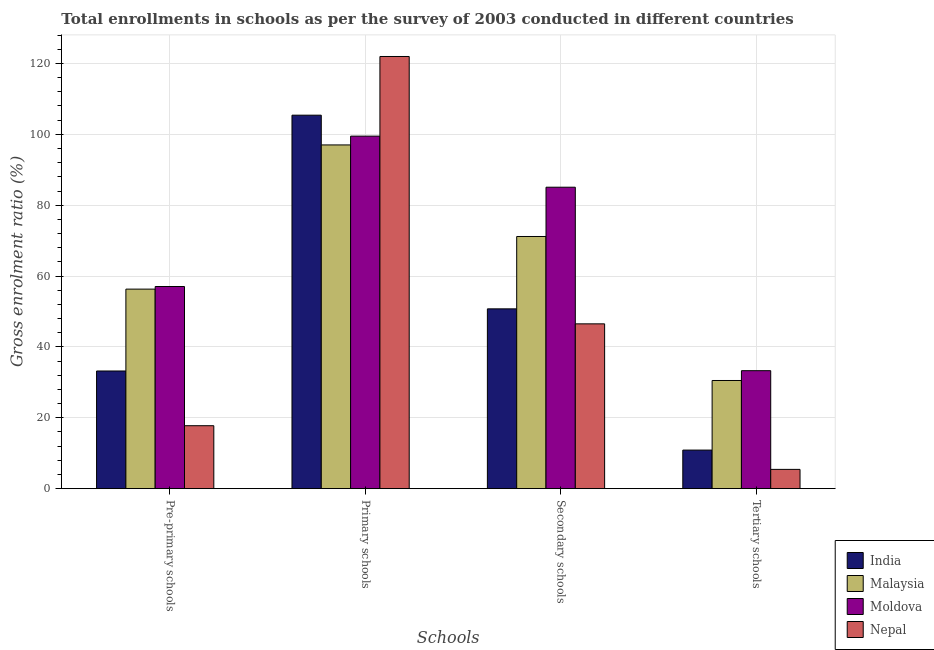How many groups of bars are there?
Make the answer very short. 4. How many bars are there on the 4th tick from the left?
Keep it short and to the point. 4. How many bars are there on the 3rd tick from the right?
Your answer should be compact. 4. What is the label of the 3rd group of bars from the left?
Ensure brevity in your answer.  Secondary schools. What is the gross enrolment ratio in pre-primary schools in Malaysia?
Keep it short and to the point. 56.31. Across all countries, what is the maximum gross enrolment ratio in pre-primary schools?
Give a very brief answer. 57.05. Across all countries, what is the minimum gross enrolment ratio in tertiary schools?
Your answer should be very brief. 5.44. In which country was the gross enrolment ratio in secondary schools maximum?
Keep it short and to the point. Moldova. In which country was the gross enrolment ratio in secondary schools minimum?
Offer a very short reply. Nepal. What is the total gross enrolment ratio in pre-primary schools in the graph?
Your answer should be compact. 164.34. What is the difference between the gross enrolment ratio in primary schools in Nepal and that in Malaysia?
Your response must be concise. 24.96. What is the difference between the gross enrolment ratio in pre-primary schools in Malaysia and the gross enrolment ratio in secondary schools in Moldova?
Provide a short and direct response. -28.76. What is the average gross enrolment ratio in primary schools per country?
Your answer should be compact. 105.96. What is the difference between the gross enrolment ratio in secondary schools and gross enrolment ratio in tertiary schools in Malaysia?
Your response must be concise. 40.64. In how many countries, is the gross enrolment ratio in pre-primary schools greater than 52 %?
Keep it short and to the point. 2. What is the ratio of the gross enrolment ratio in primary schools in Moldova to that in Nepal?
Your response must be concise. 0.82. Is the difference between the gross enrolment ratio in primary schools in India and Nepal greater than the difference between the gross enrolment ratio in secondary schools in India and Nepal?
Make the answer very short. No. What is the difference between the highest and the second highest gross enrolment ratio in primary schools?
Provide a short and direct response. 16.57. What is the difference between the highest and the lowest gross enrolment ratio in secondary schools?
Offer a terse response. 38.56. Is it the case that in every country, the sum of the gross enrolment ratio in primary schools and gross enrolment ratio in secondary schools is greater than the sum of gross enrolment ratio in pre-primary schools and gross enrolment ratio in tertiary schools?
Give a very brief answer. Yes. What does the 2nd bar from the left in Secondary schools represents?
Make the answer very short. Malaysia. What does the 3rd bar from the right in Tertiary schools represents?
Ensure brevity in your answer.  Malaysia. Is it the case that in every country, the sum of the gross enrolment ratio in pre-primary schools and gross enrolment ratio in primary schools is greater than the gross enrolment ratio in secondary schools?
Your response must be concise. Yes. What is the difference between two consecutive major ticks on the Y-axis?
Make the answer very short. 20. Are the values on the major ticks of Y-axis written in scientific E-notation?
Ensure brevity in your answer.  No. Does the graph contain any zero values?
Offer a very short reply. No. Does the graph contain grids?
Your response must be concise. Yes. Where does the legend appear in the graph?
Ensure brevity in your answer.  Bottom right. How many legend labels are there?
Provide a short and direct response. 4. What is the title of the graph?
Offer a terse response. Total enrollments in schools as per the survey of 2003 conducted in different countries. What is the label or title of the X-axis?
Your answer should be very brief. Schools. What is the label or title of the Y-axis?
Make the answer very short. Gross enrolment ratio (%). What is the Gross enrolment ratio (%) of India in Pre-primary schools?
Your response must be concise. 33.21. What is the Gross enrolment ratio (%) in Malaysia in Pre-primary schools?
Offer a very short reply. 56.31. What is the Gross enrolment ratio (%) of Moldova in Pre-primary schools?
Your response must be concise. 57.05. What is the Gross enrolment ratio (%) in Nepal in Pre-primary schools?
Ensure brevity in your answer.  17.77. What is the Gross enrolment ratio (%) of India in Primary schools?
Offer a terse response. 105.4. What is the Gross enrolment ratio (%) of Malaysia in Primary schools?
Offer a very short reply. 97. What is the Gross enrolment ratio (%) in Moldova in Primary schools?
Your answer should be compact. 99.49. What is the Gross enrolment ratio (%) of Nepal in Primary schools?
Provide a short and direct response. 121.96. What is the Gross enrolment ratio (%) in India in Secondary schools?
Provide a succinct answer. 50.75. What is the Gross enrolment ratio (%) of Malaysia in Secondary schools?
Your answer should be very brief. 71.17. What is the Gross enrolment ratio (%) of Moldova in Secondary schools?
Keep it short and to the point. 85.07. What is the Gross enrolment ratio (%) in Nepal in Secondary schools?
Your response must be concise. 46.51. What is the Gross enrolment ratio (%) of India in Tertiary schools?
Provide a short and direct response. 10.89. What is the Gross enrolment ratio (%) of Malaysia in Tertiary schools?
Provide a succinct answer. 30.53. What is the Gross enrolment ratio (%) of Moldova in Tertiary schools?
Offer a very short reply. 33.3. What is the Gross enrolment ratio (%) of Nepal in Tertiary schools?
Provide a short and direct response. 5.44. Across all Schools, what is the maximum Gross enrolment ratio (%) in India?
Your answer should be very brief. 105.4. Across all Schools, what is the maximum Gross enrolment ratio (%) of Malaysia?
Keep it short and to the point. 97. Across all Schools, what is the maximum Gross enrolment ratio (%) in Moldova?
Give a very brief answer. 99.49. Across all Schools, what is the maximum Gross enrolment ratio (%) in Nepal?
Give a very brief answer. 121.96. Across all Schools, what is the minimum Gross enrolment ratio (%) in India?
Give a very brief answer. 10.89. Across all Schools, what is the minimum Gross enrolment ratio (%) in Malaysia?
Give a very brief answer. 30.53. Across all Schools, what is the minimum Gross enrolment ratio (%) of Moldova?
Make the answer very short. 33.3. Across all Schools, what is the minimum Gross enrolment ratio (%) in Nepal?
Provide a succinct answer. 5.44. What is the total Gross enrolment ratio (%) of India in the graph?
Your answer should be very brief. 200.24. What is the total Gross enrolment ratio (%) of Malaysia in the graph?
Give a very brief answer. 255.01. What is the total Gross enrolment ratio (%) in Moldova in the graph?
Give a very brief answer. 274.91. What is the total Gross enrolment ratio (%) in Nepal in the graph?
Give a very brief answer. 191.69. What is the difference between the Gross enrolment ratio (%) in India in Pre-primary schools and that in Primary schools?
Your response must be concise. -72.19. What is the difference between the Gross enrolment ratio (%) in Malaysia in Pre-primary schools and that in Primary schools?
Make the answer very short. -40.69. What is the difference between the Gross enrolment ratio (%) of Moldova in Pre-primary schools and that in Primary schools?
Provide a succinct answer. -42.44. What is the difference between the Gross enrolment ratio (%) of Nepal in Pre-primary schools and that in Primary schools?
Offer a terse response. -104.19. What is the difference between the Gross enrolment ratio (%) in India in Pre-primary schools and that in Secondary schools?
Provide a succinct answer. -17.54. What is the difference between the Gross enrolment ratio (%) of Malaysia in Pre-primary schools and that in Secondary schools?
Offer a very short reply. -14.85. What is the difference between the Gross enrolment ratio (%) of Moldova in Pre-primary schools and that in Secondary schools?
Your response must be concise. -28.02. What is the difference between the Gross enrolment ratio (%) in Nepal in Pre-primary schools and that in Secondary schools?
Ensure brevity in your answer.  -28.74. What is the difference between the Gross enrolment ratio (%) in India in Pre-primary schools and that in Tertiary schools?
Your response must be concise. 22.32. What is the difference between the Gross enrolment ratio (%) in Malaysia in Pre-primary schools and that in Tertiary schools?
Offer a terse response. 25.78. What is the difference between the Gross enrolment ratio (%) in Moldova in Pre-primary schools and that in Tertiary schools?
Provide a succinct answer. 23.75. What is the difference between the Gross enrolment ratio (%) of Nepal in Pre-primary schools and that in Tertiary schools?
Ensure brevity in your answer.  12.33. What is the difference between the Gross enrolment ratio (%) of India in Primary schools and that in Secondary schools?
Your answer should be very brief. 54.65. What is the difference between the Gross enrolment ratio (%) of Malaysia in Primary schools and that in Secondary schools?
Offer a very short reply. 25.84. What is the difference between the Gross enrolment ratio (%) in Moldova in Primary schools and that in Secondary schools?
Your answer should be very brief. 14.41. What is the difference between the Gross enrolment ratio (%) in Nepal in Primary schools and that in Secondary schools?
Offer a terse response. 75.45. What is the difference between the Gross enrolment ratio (%) of India in Primary schools and that in Tertiary schools?
Provide a succinct answer. 94.51. What is the difference between the Gross enrolment ratio (%) of Malaysia in Primary schools and that in Tertiary schools?
Make the answer very short. 66.47. What is the difference between the Gross enrolment ratio (%) in Moldova in Primary schools and that in Tertiary schools?
Offer a terse response. 66.19. What is the difference between the Gross enrolment ratio (%) of Nepal in Primary schools and that in Tertiary schools?
Ensure brevity in your answer.  116.52. What is the difference between the Gross enrolment ratio (%) of India in Secondary schools and that in Tertiary schools?
Your response must be concise. 39.86. What is the difference between the Gross enrolment ratio (%) in Malaysia in Secondary schools and that in Tertiary schools?
Give a very brief answer. 40.64. What is the difference between the Gross enrolment ratio (%) in Moldova in Secondary schools and that in Tertiary schools?
Offer a very short reply. 51.77. What is the difference between the Gross enrolment ratio (%) in Nepal in Secondary schools and that in Tertiary schools?
Your answer should be compact. 41.07. What is the difference between the Gross enrolment ratio (%) in India in Pre-primary schools and the Gross enrolment ratio (%) in Malaysia in Primary schools?
Provide a succinct answer. -63.79. What is the difference between the Gross enrolment ratio (%) in India in Pre-primary schools and the Gross enrolment ratio (%) in Moldova in Primary schools?
Your answer should be very brief. -66.28. What is the difference between the Gross enrolment ratio (%) in India in Pre-primary schools and the Gross enrolment ratio (%) in Nepal in Primary schools?
Your answer should be compact. -88.75. What is the difference between the Gross enrolment ratio (%) of Malaysia in Pre-primary schools and the Gross enrolment ratio (%) of Moldova in Primary schools?
Offer a very short reply. -43.17. What is the difference between the Gross enrolment ratio (%) in Malaysia in Pre-primary schools and the Gross enrolment ratio (%) in Nepal in Primary schools?
Your answer should be very brief. -65.65. What is the difference between the Gross enrolment ratio (%) of Moldova in Pre-primary schools and the Gross enrolment ratio (%) of Nepal in Primary schools?
Keep it short and to the point. -64.91. What is the difference between the Gross enrolment ratio (%) of India in Pre-primary schools and the Gross enrolment ratio (%) of Malaysia in Secondary schools?
Your answer should be compact. -37.96. What is the difference between the Gross enrolment ratio (%) of India in Pre-primary schools and the Gross enrolment ratio (%) of Moldova in Secondary schools?
Make the answer very short. -51.86. What is the difference between the Gross enrolment ratio (%) in India in Pre-primary schools and the Gross enrolment ratio (%) in Nepal in Secondary schools?
Make the answer very short. -13.3. What is the difference between the Gross enrolment ratio (%) of Malaysia in Pre-primary schools and the Gross enrolment ratio (%) of Moldova in Secondary schools?
Provide a succinct answer. -28.76. What is the difference between the Gross enrolment ratio (%) in Malaysia in Pre-primary schools and the Gross enrolment ratio (%) in Nepal in Secondary schools?
Ensure brevity in your answer.  9.8. What is the difference between the Gross enrolment ratio (%) in Moldova in Pre-primary schools and the Gross enrolment ratio (%) in Nepal in Secondary schools?
Offer a very short reply. 10.53. What is the difference between the Gross enrolment ratio (%) of India in Pre-primary schools and the Gross enrolment ratio (%) of Malaysia in Tertiary schools?
Make the answer very short. 2.68. What is the difference between the Gross enrolment ratio (%) of India in Pre-primary schools and the Gross enrolment ratio (%) of Moldova in Tertiary schools?
Make the answer very short. -0.09. What is the difference between the Gross enrolment ratio (%) of India in Pre-primary schools and the Gross enrolment ratio (%) of Nepal in Tertiary schools?
Make the answer very short. 27.77. What is the difference between the Gross enrolment ratio (%) of Malaysia in Pre-primary schools and the Gross enrolment ratio (%) of Moldova in Tertiary schools?
Your answer should be very brief. 23.01. What is the difference between the Gross enrolment ratio (%) in Malaysia in Pre-primary schools and the Gross enrolment ratio (%) in Nepal in Tertiary schools?
Your answer should be compact. 50.87. What is the difference between the Gross enrolment ratio (%) in Moldova in Pre-primary schools and the Gross enrolment ratio (%) in Nepal in Tertiary schools?
Your answer should be compact. 51.6. What is the difference between the Gross enrolment ratio (%) in India in Primary schools and the Gross enrolment ratio (%) in Malaysia in Secondary schools?
Your answer should be very brief. 34.23. What is the difference between the Gross enrolment ratio (%) of India in Primary schools and the Gross enrolment ratio (%) of Moldova in Secondary schools?
Give a very brief answer. 20.32. What is the difference between the Gross enrolment ratio (%) in India in Primary schools and the Gross enrolment ratio (%) in Nepal in Secondary schools?
Keep it short and to the point. 58.88. What is the difference between the Gross enrolment ratio (%) in Malaysia in Primary schools and the Gross enrolment ratio (%) in Moldova in Secondary schools?
Make the answer very short. 11.93. What is the difference between the Gross enrolment ratio (%) in Malaysia in Primary schools and the Gross enrolment ratio (%) in Nepal in Secondary schools?
Give a very brief answer. 50.49. What is the difference between the Gross enrolment ratio (%) in Moldova in Primary schools and the Gross enrolment ratio (%) in Nepal in Secondary schools?
Offer a terse response. 52.97. What is the difference between the Gross enrolment ratio (%) of India in Primary schools and the Gross enrolment ratio (%) of Malaysia in Tertiary schools?
Provide a short and direct response. 74.87. What is the difference between the Gross enrolment ratio (%) in India in Primary schools and the Gross enrolment ratio (%) in Moldova in Tertiary schools?
Your response must be concise. 72.1. What is the difference between the Gross enrolment ratio (%) in India in Primary schools and the Gross enrolment ratio (%) in Nepal in Tertiary schools?
Offer a terse response. 99.95. What is the difference between the Gross enrolment ratio (%) in Malaysia in Primary schools and the Gross enrolment ratio (%) in Moldova in Tertiary schools?
Your answer should be compact. 63.7. What is the difference between the Gross enrolment ratio (%) in Malaysia in Primary schools and the Gross enrolment ratio (%) in Nepal in Tertiary schools?
Your answer should be very brief. 91.56. What is the difference between the Gross enrolment ratio (%) in Moldova in Primary schools and the Gross enrolment ratio (%) in Nepal in Tertiary schools?
Your response must be concise. 94.04. What is the difference between the Gross enrolment ratio (%) in India in Secondary schools and the Gross enrolment ratio (%) in Malaysia in Tertiary schools?
Provide a succinct answer. 20.22. What is the difference between the Gross enrolment ratio (%) in India in Secondary schools and the Gross enrolment ratio (%) in Moldova in Tertiary schools?
Provide a short and direct response. 17.45. What is the difference between the Gross enrolment ratio (%) in India in Secondary schools and the Gross enrolment ratio (%) in Nepal in Tertiary schools?
Your answer should be compact. 45.3. What is the difference between the Gross enrolment ratio (%) of Malaysia in Secondary schools and the Gross enrolment ratio (%) of Moldova in Tertiary schools?
Provide a short and direct response. 37.87. What is the difference between the Gross enrolment ratio (%) in Malaysia in Secondary schools and the Gross enrolment ratio (%) in Nepal in Tertiary schools?
Offer a very short reply. 65.72. What is the difference between the Gross enrolment ratio (%) of Moldova in Secondary schools and the Gross enrolment ratio (%) of Nepal in Tertiary schools?
Your answer should be compact. 79.63. What is the average Gross enrolment ratio (%) of India per Schools?
Offer a very short reply. 50.06. What is the average Gross enrolment ratio (%) of Malaysia per Schools?
Offer a very short reply. 63.75. What is the average Gross enrolment ratio (%) in Moldova per Schools?
Make the answer very short. 68.73. What is the average Gross enrolment ratio (%) in Nepal per Schools?
Give a very brief answer. 47.92. What is the difference between the Gross enrolment ratio (%) of India and Gross enrolment ratio (%) of Malaysia in Pre-primary schools?
Give a very brief answer. -23.1. What is the difference between the Gross enrolment ratio (%) in India and Gross enrolment ratio (%) in Moldova in Pre-primary schools?
Provide a short and direct response. -23.84. What is the difference between the Gross enrolment ratio (%) in India and Gross enrolment ratio (%) in Nepal in Pre-primary schools?
Give a very brief answer. 15.44. What is the difference between the Gross enrolment ratio (%) of Malaysia and Gross enrolment ratio (%) of Moldova in Pre-primary schools?
Keep it short and to the point. -0.74. What is the difference between the Gross enrolment ratio (%) in Malaysia and Gross enrolment ratio (%) in Nepal in Pre-primary schools?
Make the answer very short. 38.54. What is the difference between the Gross enrolment ratio (%) in Moldova and Gross enrolment ratio (%) in Nepal in Pre-primary schools?
Ensure brevity in your answer.  39.28. What is the difference between the Gross enrolment ratio (%) in India and Gross enrolment ratio (%) in Malaysia in Primary schools?
Your answer should be very brief. 8.39. What is the difference between the Gross enrolment ratio (%) in India and Gross enrolment ratio (%) in Moldova in Primary schools?
Offer a terse response. 5.91. What is the difference between the Gross enrolment ratio (%) of India and Gross enrolment ratio (%) of Nepal in Primary schools?
Offer a terse response. -16.57. What is the difference between the Gross enrolment ratio (%) of Malaysia and Gross enrolment ratio (%) of Moldova in Primary schools?
Provide a succinct answer. -2.48. What is the difference between the Gross enrolment ratio (%) in Malaysia and Gross enrolment ratio (%) in Nepal in Primary schools?
Offer a very short reply. -24.96. What is the difference between the Gross enrolment ratio (%) in Moldova and Gross enrolment ratio (%) in Nepal in Primary schools?
Provide a succinct answer. -22.48. What is the difference between the Gross enrolment ratio (%) of India and Gross enrolment ratio (%) of Malaysia in Secondary schools?
Ensure brevity in your answer.  -20.42. What is the difference between the Gross enrolment ratio (%) in India and Gross enrolment ratio (%) in Moldova in Secondary schools?
Keep it short and to the point. -34.33. What is the difference between the Gross enrolment ratio (%) in India and Gross enrolment ratio (%) in Nepal in Secondary schools?
Your response must be concise. 4.23. What is the difference between the Gross enrolment ratio (%) in Malaysia and Gross enrolment ratio (%) in Moldova in Secondary schools?
Provide a short and direct response. -13.91. What is the difference between the Gross enrolment ratio (%) of Malaysia and Gross enrolment ratio (%) of Nepal in Secondary schools?
Keep it short and to the point. 24.65. What is the difference between the Gross enrolment ratio (%) in Moldova and Gross enrolment ratio (%) in Nepal in Secondary schools?
Make the answer very short. 38.56. What is the difference between the Gross enrolment ratio (%) of India and Gross enrolment ratio (%) of Malaysia in Tertiary schools?
Keep it short and to the point. -19.64. What is the difference between the Gross enrolment ratio (%) in India and Gross enrolment ratio (%) in Moldova in Tertiary schools?
Offer a terse response. -22.41. What is the difference between the Gross enrolment ratio (%) in India and Gross enrolment ratio (%) in Nepal in Tertiary schools?
Make the answer very short. 5.44. What is the difference between the Gross enrolment ratio (%) in Malaysia and Gross enrolment ratio (%) in Moldova in Tertiary schools?
Make the answer very short. -2.77. What is the difference between the Gross enrolment ratio (%) in Malaysia and Gross enrolment ratio (%) in Nepal in Tertiary schools?
Your answer should be compact. 25.09. What is the difference between the Gross enrolment ratio (%) in Moldova and Gross enrolment ratio (%) in Nepal in Tertiary schools?
Offer a very short reply. 27.85. What is the ratio of the Gross enrolment ratio (%) in India in Pre-primary schools to that in Primary schools?
Ensure brevity in your answer.  0.32. What is the ratio of the Gross enrolment ratio (%) of Malaysia in Pre-primary schools to that in Primary schools?
Offer a very short reply. 0.58. What is the ratio of the Gross enrolment ratio (%) in Moldova in Pre-primary schools to that in Primary schools?
Your answer should be compact. 0.57. What is the ratio of the Gross enrolment ratio (%) in Nepal in Pre-primary schools to that in Primary schools?
Your answer should be very brief. 0.15. What is the ratio of the Gross enrolment ratio (%) of India in Pre-primary schools to that in Secondary schools?
Offer a very short reply. 0.65. What is the ratio of the Gross enrolment ratio (%) of Malaysia in Pre-primary schools to that in Secondary schools?
Provide a succinct answer. 0.79. What is the ratio of the Gross enrolment ratio (%) of Moldova in Pre-primary schools to that in Secondary schools?
Provide a succinct answer. 0.67. What is the ratio of the Gross enrolment ratio (%) of Nepal in Pre-primary schools to that in Secondary schools?
Your answer should be very brief. 0.38. What is the ratio of the Gross enrolment ratio (%) of India in Pre-primary schools to that in Tertiary schools?
Give a very brief answer. 3.05. What is the ratio of the Gross enrolment ratio (%) of Malaysia in Pre-primary schools to that in Tertiary schools?
Provide a succinct answer. 1.84. What is the ratio of the Gross enrolment ratio (%) of Moldova in Pre-primary schools to that in Tertiary schools?
Offer a terse response. 1.71. What is the ratio of the Gross enrolment ratio (%) in Nepal in Pre-primary schools to that in Tertiary schools?
Your response must be concise. 3.26. What is the ratio of the Gross enrolment ratio (%) of India in Primary schools to that in Secondary schools?
Provide a short and direct response. 2.08. What is the ratio of the Gross enrolment ratio (%) of Malaysia in Primary schools to that in Secondary schools?
Offer a very short reply. 1.36. What is the ratio of the Gross enrolment ratio (%) of Moldova in Primary schools to that in Secondary schools?
Your response must be concise. 1.17. What is the ratio of the Gross enrolment ratio (%) in Nepal in Primary schools to that in Secondary schools?
Make the answer very short. 2.62. What is the ratio of the Gross enrolment ratio (%) of India in Primary schools to that in Tertiary schools?
Your answer should be very brief. 9.68. What is the ratio of the Gross enrolment ratio (%) of Malaysia in Primary schools to that in Tertiary schools?
Provide a succinct answer. 3.18. What is the ratio of the Gross enrolment ratio (%) in Moldova in Primary schools to that in Tertiary schools?
Ensure brevity in your answer.  2.99. What is the ratio of the Gross enrolment ratio (%) in Nepal in Primary schools to that in Tertiary schools?
Make the answer very short. 22.4. What is the ratio of the Gross enrolment ratio (%) of India in Secondary schools to that in Tertiary schools?
Your response must be concise. 4.66. What is the ratio of the Gross enrolment ratio (%) in Malaysia in Secondary schools to that in Tertiary schools?
Your response must be concise. 2.33. What is the ratio of the Gross enrolment ratio (%) of Moldova in Secondary schools to that in Tertiary schools?
Your answer should be compact. 2.55. What is the ratio of the Gross enrolment ratio (%) in Nepal in Secondary schools to that in Tertiary schools?
Keep it short and to the point. 8.54. What is the difference between the highest and the second highest Gross enrolment ratio (%) in India?
Keep it short and to the point. 54.65. What is the difference between the highest and the second highest Gross enrolment ratio (%) in Malaysia?
Make the answer very short. 25.84. What is the difference between the highest and the second highest Gross enrolment ratio (%) in Moldova?
Your response must be concise. 14.41. What is the difference between the highest and the second highest Gross enrolment ratio (%) of Nepal?
Make the answer very short. 75.45. What is the difference between the highest and the lowest Gross enrolment ratio (%) in India?
Keep it short and to the point. 94.51. What is the difference between the highest and the lowest Gross enrolment ratio (%) of Malaysia?
Ensure brevity in your answer.  66.47. What is the difference between the highest and the lowest Gross enrolment ratio (%) of Moldova?
Provide a succinct answer. 66.19. What is the difference between the highest and the lowest Gross enrolment ratio (%) of Nepal?
Your answer should be compact. 116.52. 